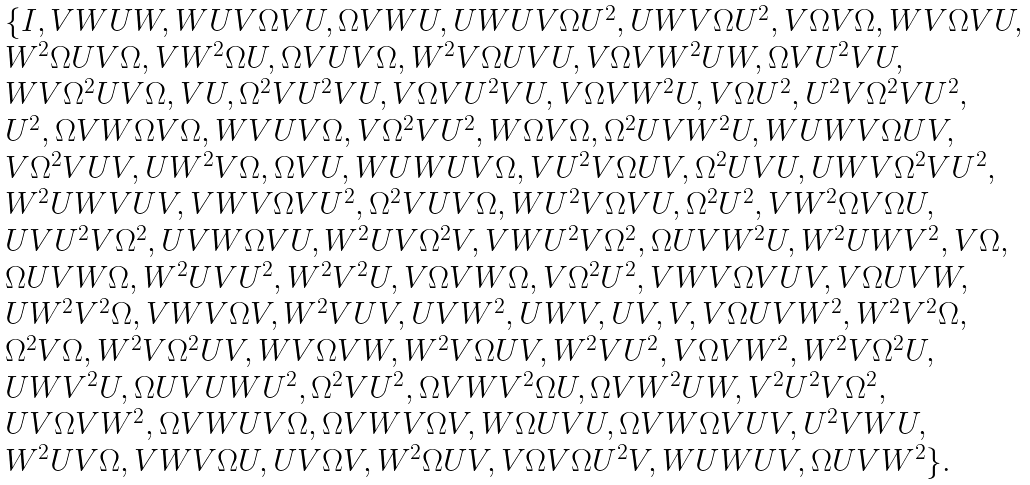Convert formula to latex. <formula><loc_0><loc_0><loc_500><loc_500>\begin{array} { l l l } \{ I , V W U W , W U V \Omega V U , \Omega V W U , U W U V \Omega U ^ { 2 } , U W V \Omega U ^ { 2 } , V \Omega V \Omega , W V \Omega V U , \\ W ^ { 2 } \Omega U V \Omega , V W ^ { 2 } \Omega U , \Omega V U V \Omega , W ^ { 2 } V \Omega U V U , V \Omega V W ^ { 2 } U W , \Omega V U ^ { 2 } V U , \\ W V \Omega ^ { 2 } U V \Omega , V U , \Omega ^ { 2 } V U ^ { 2 } V U , V \Omega V U ^ { 2 } V U , V \Omega V W ^ { 2 } U , V \Omega U ^ { 2 } , U ^ { 2 } V \Omega ^ { 2 } V U ^ { 2 } , \\ U ^ { 2 } , \Omega V W \Omega V \Omega , W V U V \Omega , V \Omega ^ { 2 } V U ^ { 2 } , W \Omega V \Omega , \Omega ^ { 2 } U V W ^ { 2 } U , W U W V \Omega U V , \\ V \Omega ^ { 2 } V U V , U W ^ { 2 } V \Omega , \Omega V U , W U W U V \Omega , V U ^ { 2 } V \Omega U V , \Omega ^ { 2 } U V U , U W V \Omega ^ { 2 } V U ^ { 2 } , \\ W ^ { 2 } U W V U V , V W V \Omega V U ^ { 2 } , \Omega ^ { 2 } V U V \Omega , W U ^ { 2 } V \Omega V U , \Omega ^ { 2 } U ^ { 2 } , V W ^ { 2 } \Omega V \Omega U , \\ U V U ^ { 2 } V \Omega ^ { 2 } , U V W \Omega V U , W ^ { 2 } U V \Omega ^ { 2 } V , V W U ^ { 2 } V \Omega ^ { 2 } , \Omega U V W ^ { 2 } U , W ^ { 2 } U W V ^ { 2 } , V \Omega , \\ \Omega U V W \Omega , W ^ { 2 } U V U ^ { 2 } , W ^ { 2 } V ^ { 2 } U , V \Omega V W \Omega , V \Omega ^ { 2 } U ^ { 2 } , V W V \Omega V U V , V \Omega U V W , \\ U W ^ { 2 } V ^ { 2 } \Omega , V W V \Omega V , W ^ { 2 } V U V , U V W ^ { 2 } , U W V , U V , V , V \Omega U V W ^ { 2 } , W ^ { 2 } V ^ { 2 } \Omega , \\ \Omega ^ { 2 } V \Omega , W ^ { 2 } V \Omega ^ { 2 } U V , W V \Omega V W , W ^ { 2 } V \Omega U V , W ^ { 2 } V U ^ { 2 } , V \Omega V W ^ { 2 } , W ^ { 2 } V \Omega ^ { 2 } U , \\ U W V ^ { 2 } U , \Omega U V U W U ^ { 2 } , \Omega ^ { 2 } V U ^ { 2 } , \Omega V W V ^ { 2 } \Omega U , \Omega V W ^ { 2 } U W , V ^ { 2 } U ^ { 2 } V \Omega ^ { 2 } , \\ U V \Omega V W ^ { 2 } , \Omega V W U V \Omega , \Omega V W V \Omega V , W \Omega U V U , \Omega V W \Omega V U V , U ^ { 2 } V W U , \\ W ^ { 2 } U V \Omega , V W V \Omega U , U V \Omega V , W ^ { 2 } \Omega U V , V \Omega V \Omega U ^ { 2 } V , W U W U V , \Omega U V W ^ { 2 } \} . \end{array}</formula> 